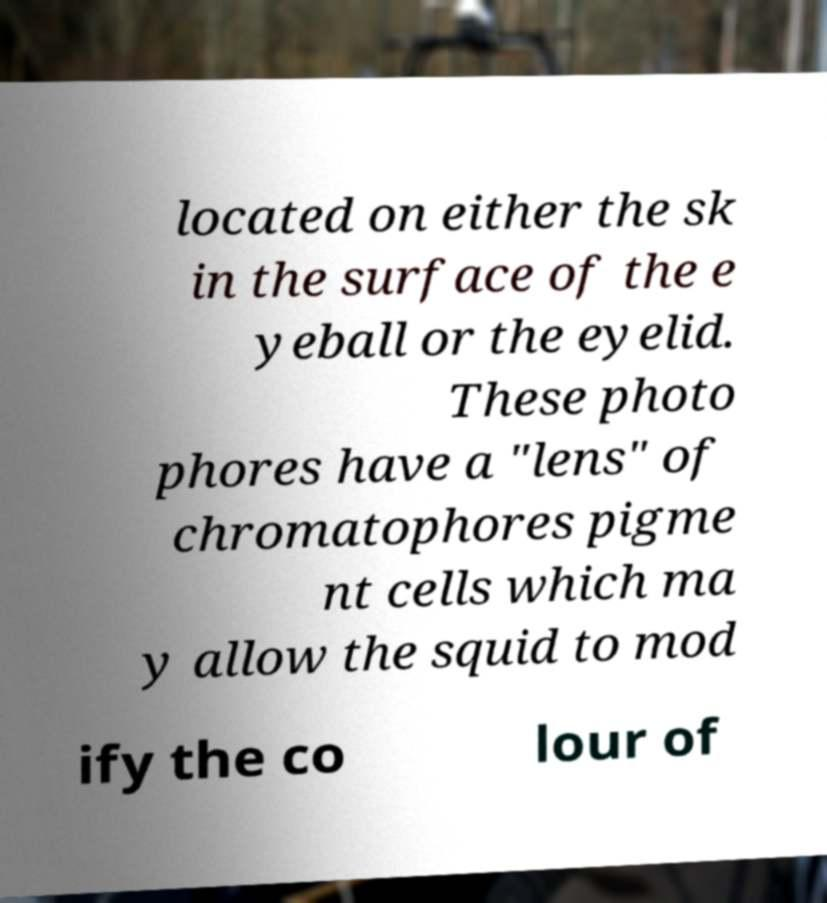Can you read and provide the text displayed in the image?This photo seems to have some interesting text. Can you extract and type it out for me? located on either the sk in the surface of the e yeball or the eyelid. These photo phores have a "lens" of chromatophores pigme nt cells which ma y allow the squid to mod ify the co lour of 